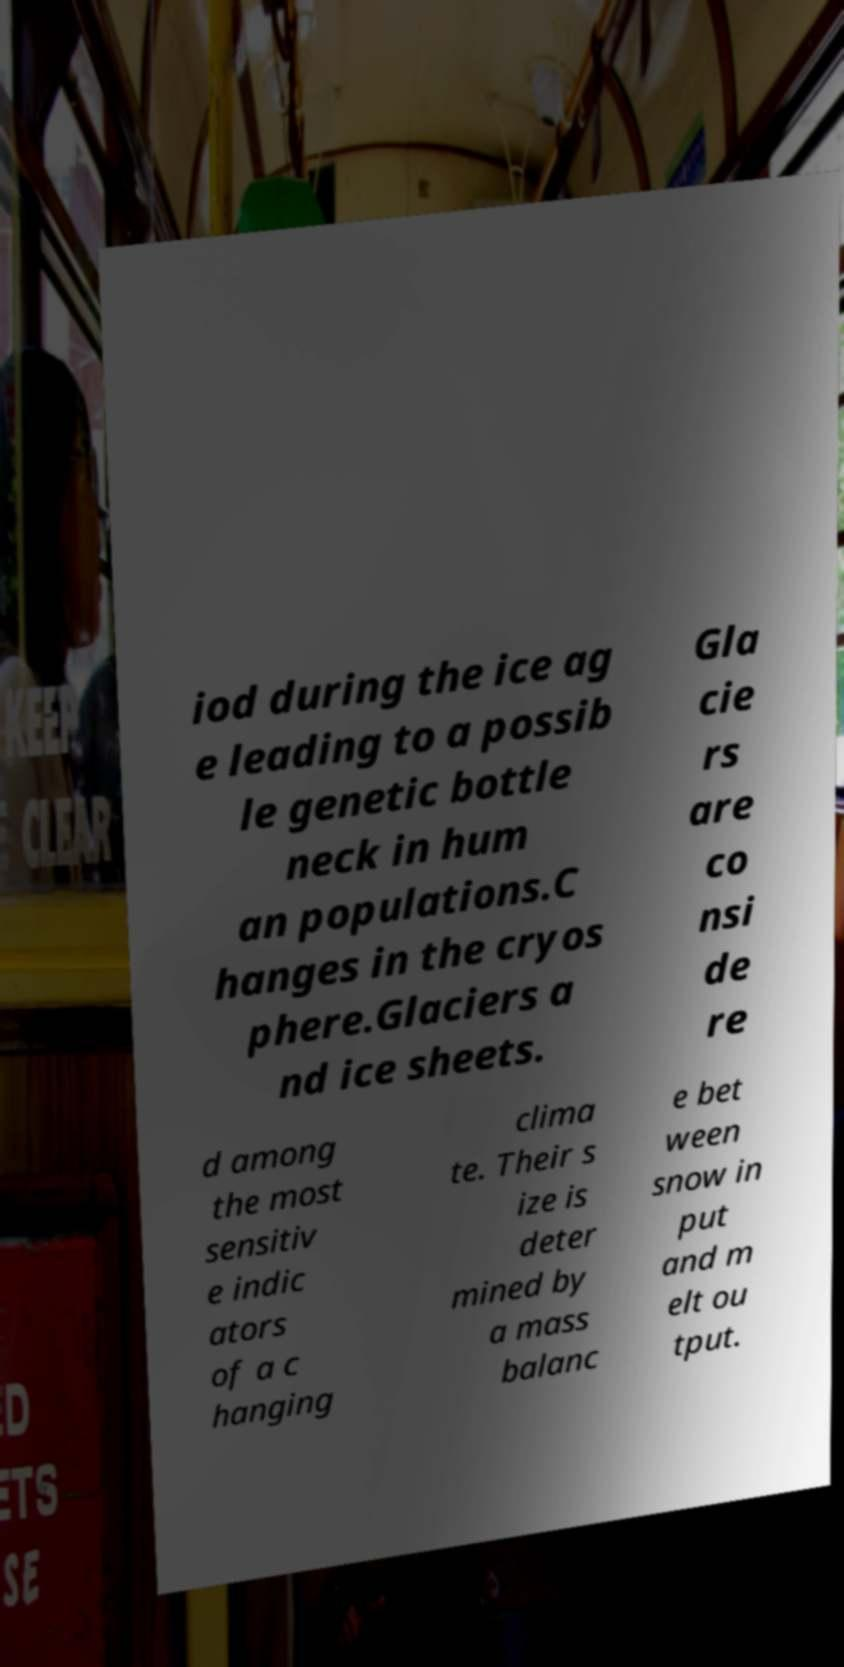Could you assist in decoding the text presented in this image and type it out clearly? iod during the ice ag e leading to a possib le genetic bottle neck in hum an populations.C hanges in the cryos phere.Glaciers a nd ice sheets. Gla cie rs are co nsi de re d among the most sensitiv e indic ators of a c hanging clima te. Their s ize is deter mined by a mass balanc e bet ween snow in put and m elt ou tput. 